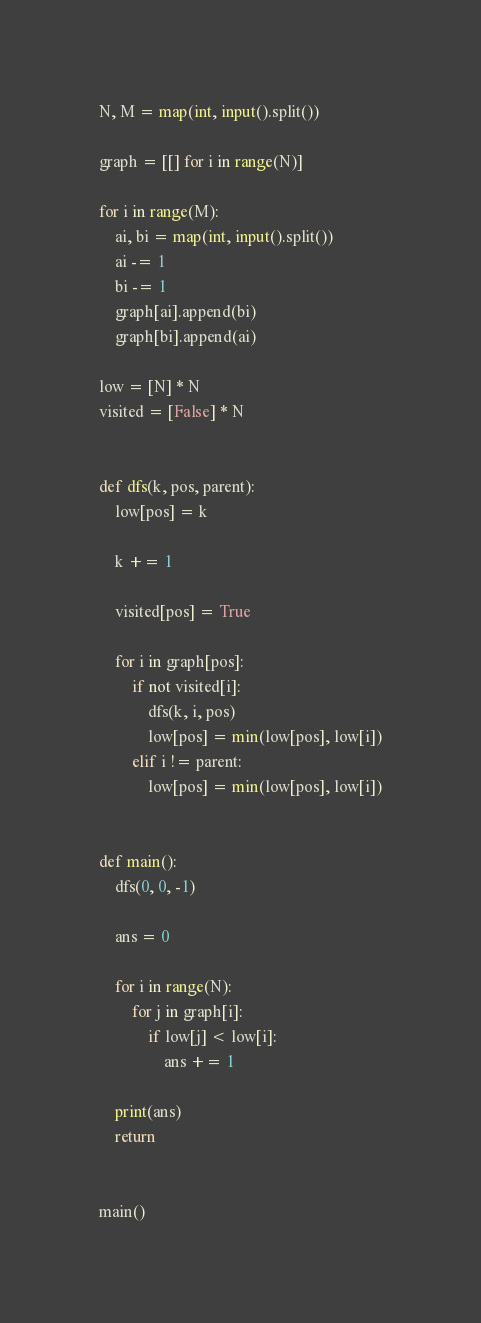Convert code to text. <code><loc_0><loc_0><loc_500><loc_500><_Python_>N, M = map(int, input().split())

graph = [[] for i in range(N)]

for i in range(M):
    ai, bi = map(int, input().split())
    ai -= 1
    bi -= 1
    graph[ai].append(bi)
    graph[bi].append(ai)

low = [N] * N
visited = [False] * N


def dfs(k, pos, parent):
    low[pos] = k

    k += 1

    visited[pos] = True

    for i in graph[pos]:
        if not visited[i]:
            dfs(k, i, pos)
            low[pos] = min(low[pos], low[i])
        elif i != parent:
            low[pos] = min(low[pos], low[i])


def main():
    dfs(0, 0, -1)

    ans = 0

    for i in range(N):
        for j in graph[i]:
            if low[j] < low[i]:
                ans += 1

    print(ans)
    return


main()
</code> 